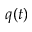<formula> <loc_0><loc_0><loc_500><loc_500>q ( t )</formula> 